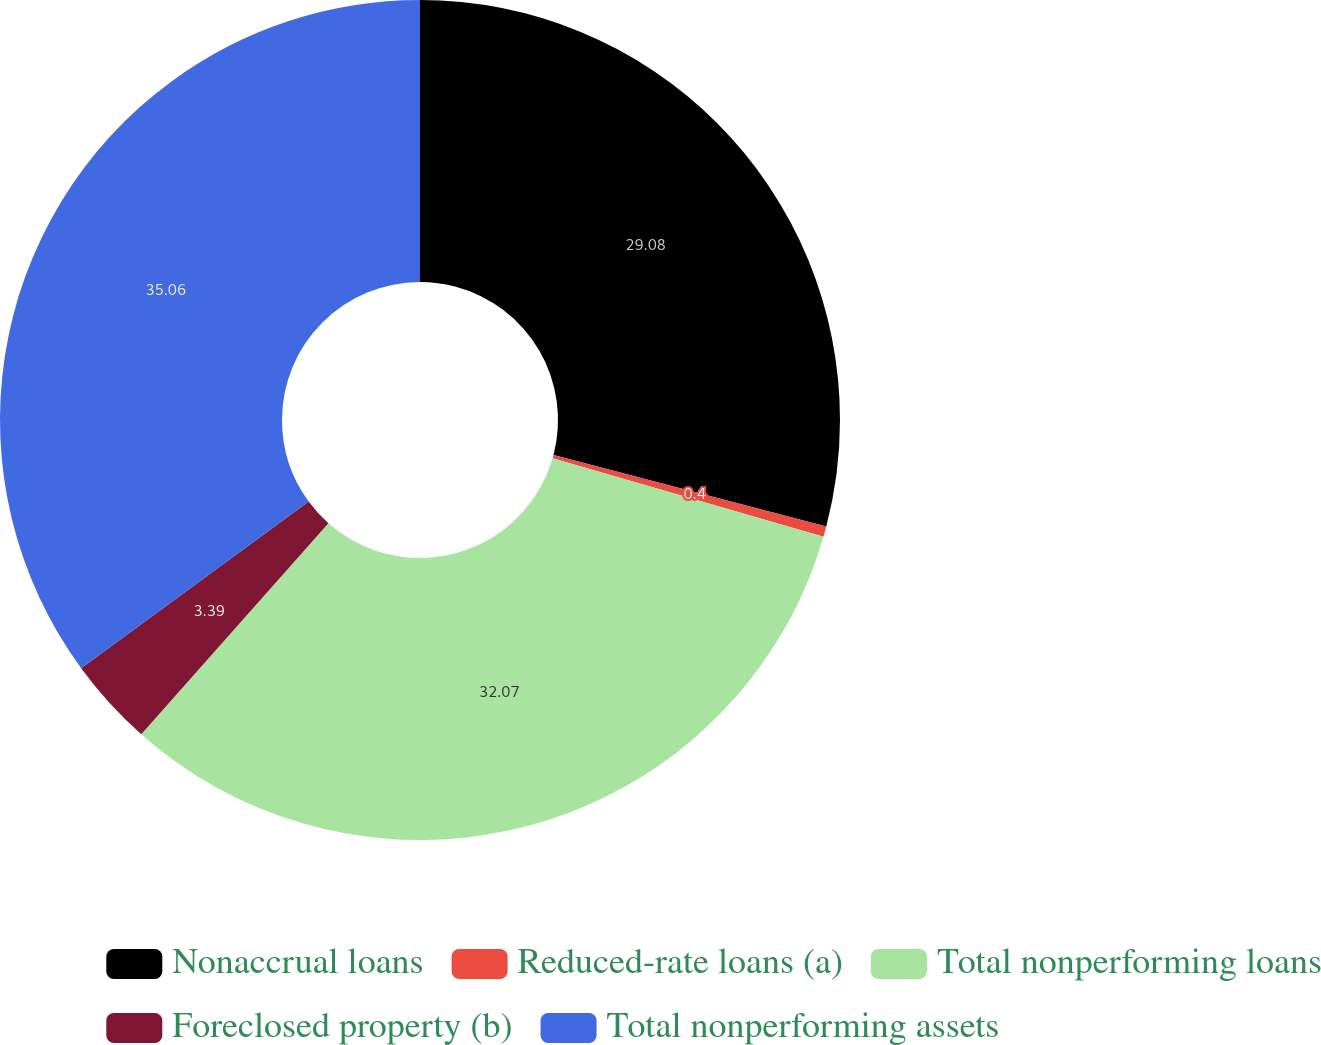<chart> <loc_0><loc_0><loc_500><loc_500><pie_chart><fcel>Nonaccrual loans<fcel>Reduced-rate loans (a)<fcel>Total nonperforming loans<fcel>Foreclosed property (b)<fcel>Total nonperforming assets<nl><fcel>29.08%<fcel>0.4%<fcel>32.07%<fcel>3.39%<fcel>35.06%<nl></chart> 